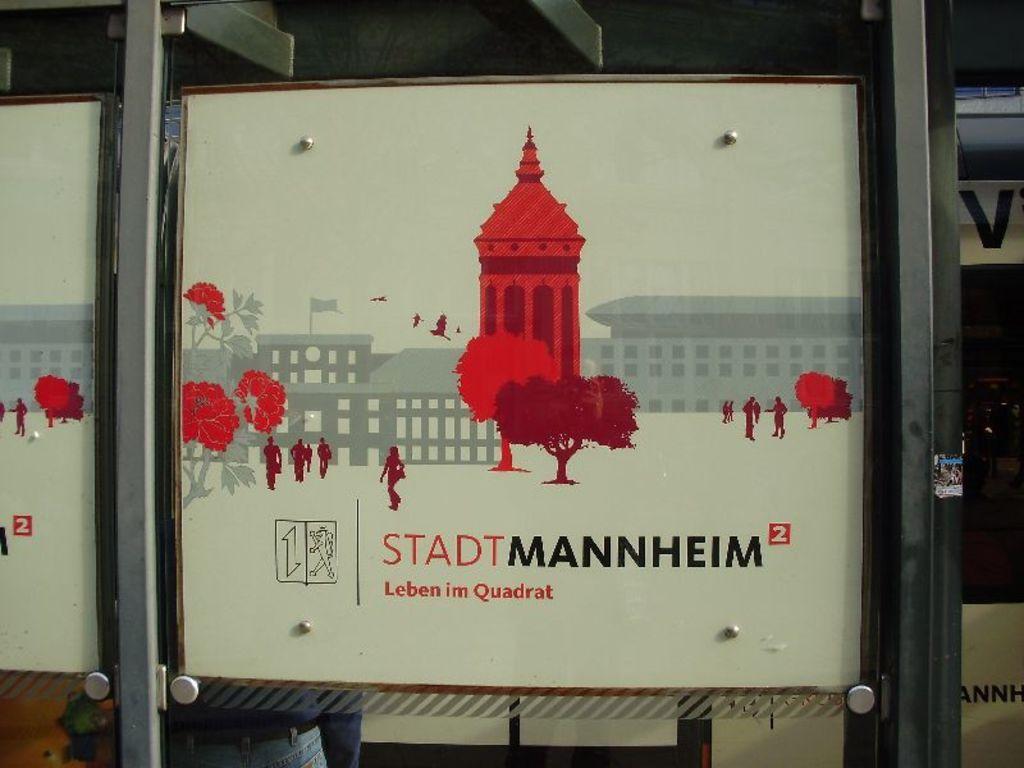How would you summarize this image in a sentence or two? In this picture, we can see the glass door, poster with some text and images on it, we can see a person from the glass door. 